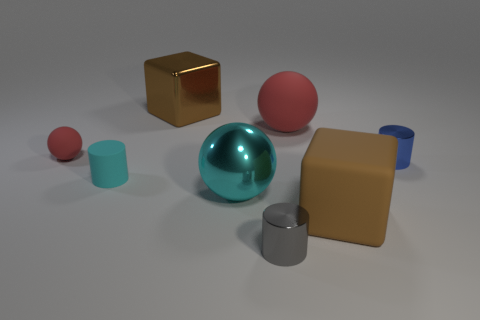How many metal objects are in front of the big metallic block and behind the small gray cylinder?
Provide a short and direct response. 2. Are there any green cylinders made of the same material as the cyan sphere?
Ensure brevity in your answer.  No. What is the material of the big block that is right of the big brown cube that is left of the big cyan shiny thing?
Ensure brevity in your answer.  Rubber. Is the number of big cyan metallic things in front of the brown rubber thing the same as the number of small gray cylinders that are in front of the small red sphere?
Your answer should be compact. No. Is the small cyan matte object the same shape as the tiny red object?
Ensure brevity in your answer.  No. There is a large thing that is both in front of the tiny red thing and behind the brown matte thing; what is its material?
Keep it short and to the point. Metal. How many tiny brown things have the same shape as the big red rubber thing?
Your response must be concise. 0. There is a red rubber sphere to the left of the red rubber sphere that is right of the red matte thing on the left side of the large red object; what is its size?
Ensure brevity in your answer.  Small. Is the number of large brown rubber objects that are behind the matte cube greater than the number of large things?
Give a very brief answer. No. Are there any small red matte objects?
Offer a terse response. Yes. 